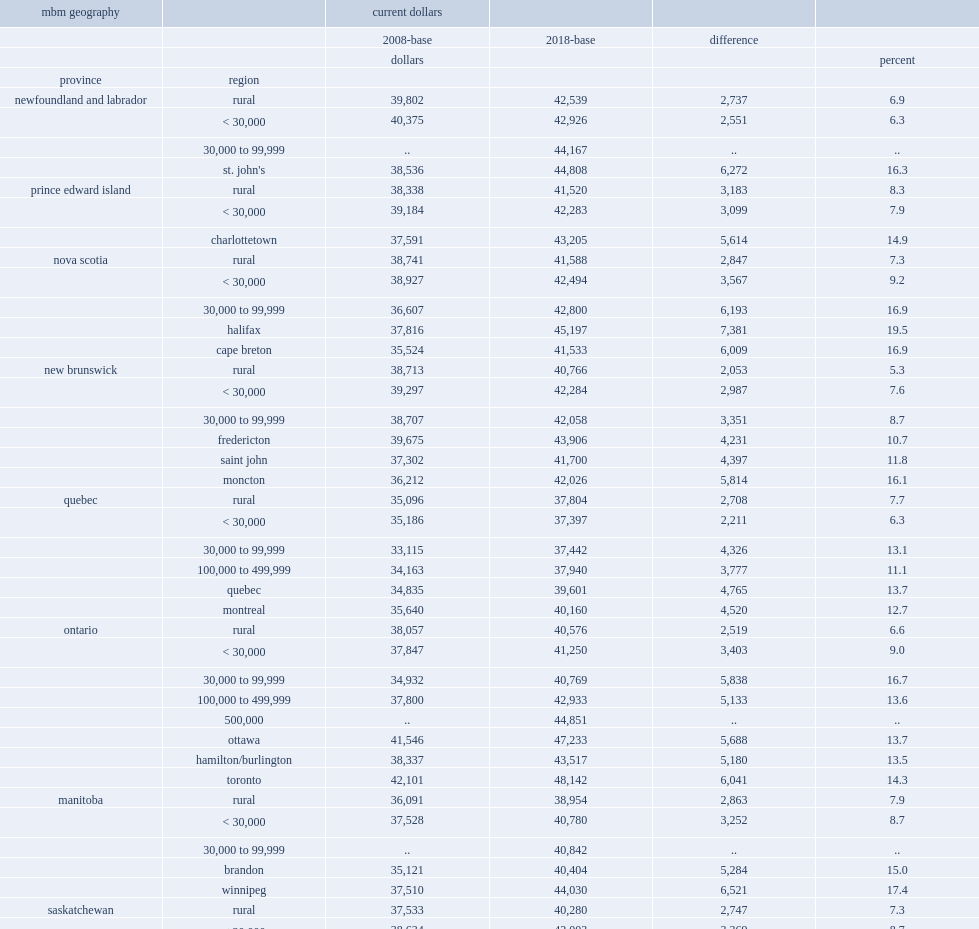For vancouver, what is the mbm threshold for a family of four under the 2008-base methodology? 40644.0. For vancouver, what is the mbm threshold for a family of four under the 2018-base methodology? 48677.0. For vancouver, how many dollars of the mbm threshold for a family of four under has increased from 2008-base methodology to the 2018-base methodology? 8033.0. 